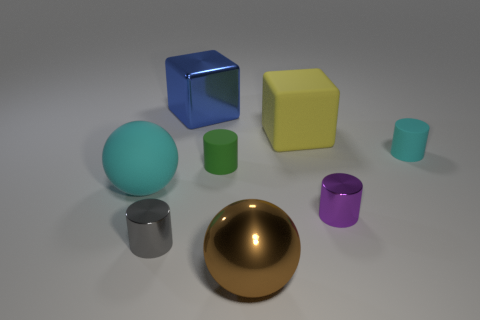There is a metal object that is left of the blue thing; how big is it?
Offer a very short reply. Small. There is a cyan thing that is the same shape as the small purple metal object; what material is it?
Offer a terse response. Rubber. Are there any other things that are the same size as the blue object?
Ensure brevity in your answer.  Yes. What shape is the gray metal object on the left side of the large yellow thing?
Provide a succinct answer. Cylinder. What number of yellow objects are the same shape as the big blue shiny object?
Your answer should be compact. 1. Is the number of large cyan things behind the yellow cube the same as the number of big cubes that are in front of the tiny cyan matte object?
Offer a very short reply. Yes. Is there a blue object made of the same material as the big yellow cube?
Provide a succinct answer. No. Is the big brown sphere made of the same material as the tiny gray cylinder?
Make the answer very short. Yes. How many purple objects are either tiny metallic cylinders or large blocks?
Your answer should be compact. 1. Are there more green cylinders that are behind the gray shiny cylinder than big balls?
Ensure brevity in your answer.  No. 